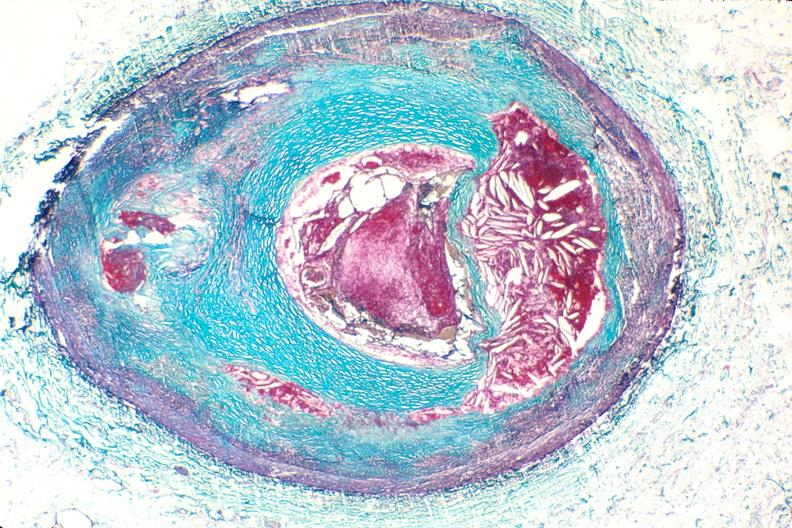s mesothelioma present?
Answer the question using a single word or phrase. No 